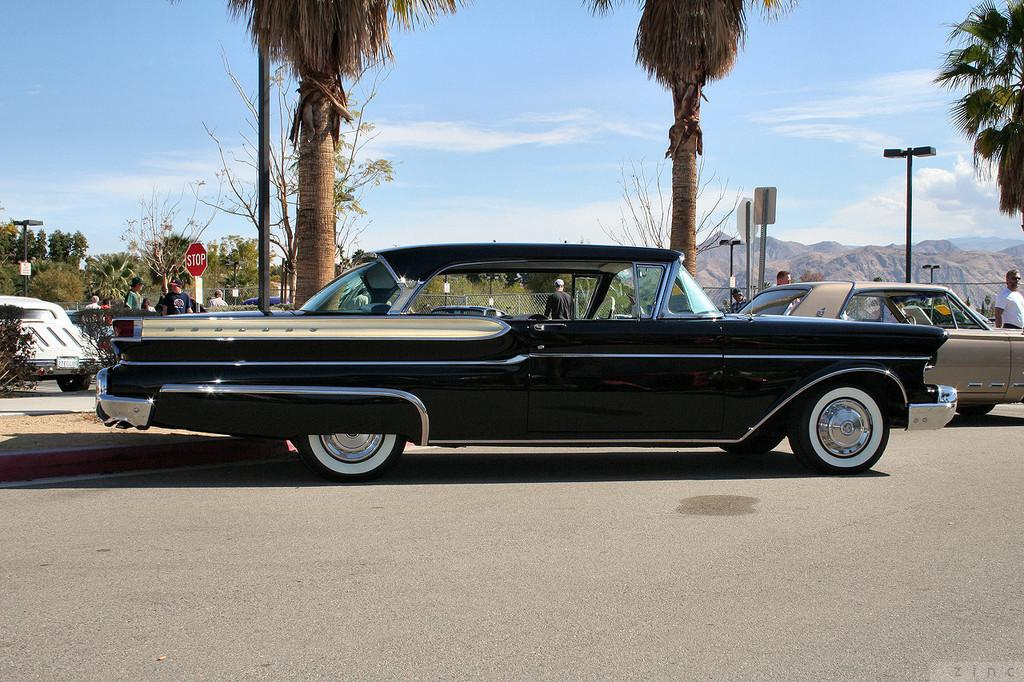What types of objects can be seen in the image? There are vehicles, people, trees, plants, poles, lights, boards, mountains, and a fence visible in the image. Can you describe the natural elements in the image? There are trees, plants, mountains, and a fence visible in the image. What can be seen in the sky in the image? The sky is visible in the background of the image, and there are clouds present. What type of artificial structures can be seen in the image? There are poles, lights, and boards visible in the image. What type of cracker is being spread with jam on the fence in the image? There is no cracker or jam present in the image; the image does not depict any food items. Can you tell me the name of the father in the image? There is no mention of a father or any specific individuals in the image. 